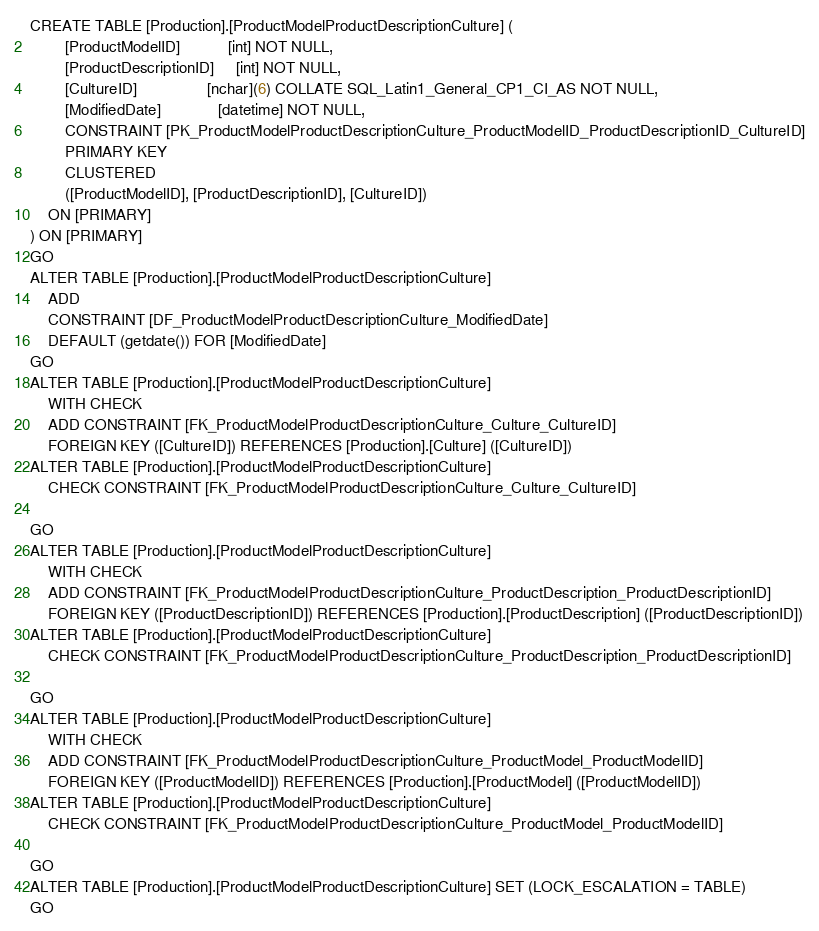<code> <loc_0><loc_0><loc_500><loc_500><_SQL_>CREATE TABLE [Production].[ProductModelProductDescriptionCulture] (
		[ProductModelID]           [int] NOT NULL,
		[ProductDescriptionID]     [int] NOT NULL,
		[CultureID]                [nchar](6) COLLATE SQL_Latin1_General_CP1_CI_AS NOT NULL,
		[ModifiedDate]             [datetime] NOT NULL,
		CONSTRAINT [PK_ProductModelProductDescriptionCulture_ProductModelID_ProductDescriptionID_CultureID]
		PRIMARY KEY
		CLUSTERED
		([ProductModelID], [ProductDescriptionID], [CultureID])
	ON [PRIMARY]
) ON [PRIMARY]
GO
ALTER TABLE [Production].[ProductModelProductDescriptionCulture]
	ADD
	CONSTRAINT [DF_ProductModelProductDescriptionCulture_ModifiedDate]
	DEFAULT (getdate()) FOR [ModifiedDate]
GO
ALTER TABLE [Production].[ProductModelProductDescriptionCulture]
	WITH CHECK
	ADD CONSTRAINT [FK_ProductModelProductDescriptionCulture_Culture_CultureID]
	FOREIGN KEY ([CultureID]) REFERENCES [Production].[Culture] ([CultureID])
ALTER TABLE [Production].[ProductModelProductDescriptionCulture]
	CHECK CONSTRAINT [FK_ProductModelProductDescriptionCulture_Culture_CultureID]

GO
ALTER TABLE [Production].[ProductModelProductDescriptionCulture]
	WITH CHECK
	ADD CONSTRAINT [FK_ProductModelProductDescriptionCulture_ProductDescription_ProductDescriptionID]
	FOREIGN KEY ([ProductDescriptionID]) REFERENCES [Production].[ProductDescription] ([ProductDescriptionID])
ALTER TABLE [Production].[ProductModelProductDescriptionCulture]
	CHECK CONSTRAINT [FK_ProductModelProductDescriptionCulture_ProductDescription_ProductDescriptionID]

GO
ALTER TABLE [Production].[ProductModelProductDescriptionCulture]
	WITH CHECK
	ADD CONSTRAINT [FK_ProductModelProductDescriptionCulture_ProductModel_ProductModelID]
	FOREIGN KEY ([ProductModelID]) REFERENCES [Production].[ProductModel] ([ProductModelID])
ALTER TABLE [Production].[ProductModelProductDescriptionCulture]
	CHECK CONSTRAINT [FK_ProductModelProductDescriptionCulture_ProductModel_ProductModelID]

GO
ALTER TABLE [Production].[ProductModelProductDescriptionCulture] SET (LOCK_ESCALATION = TABLE)
GO
</code> 